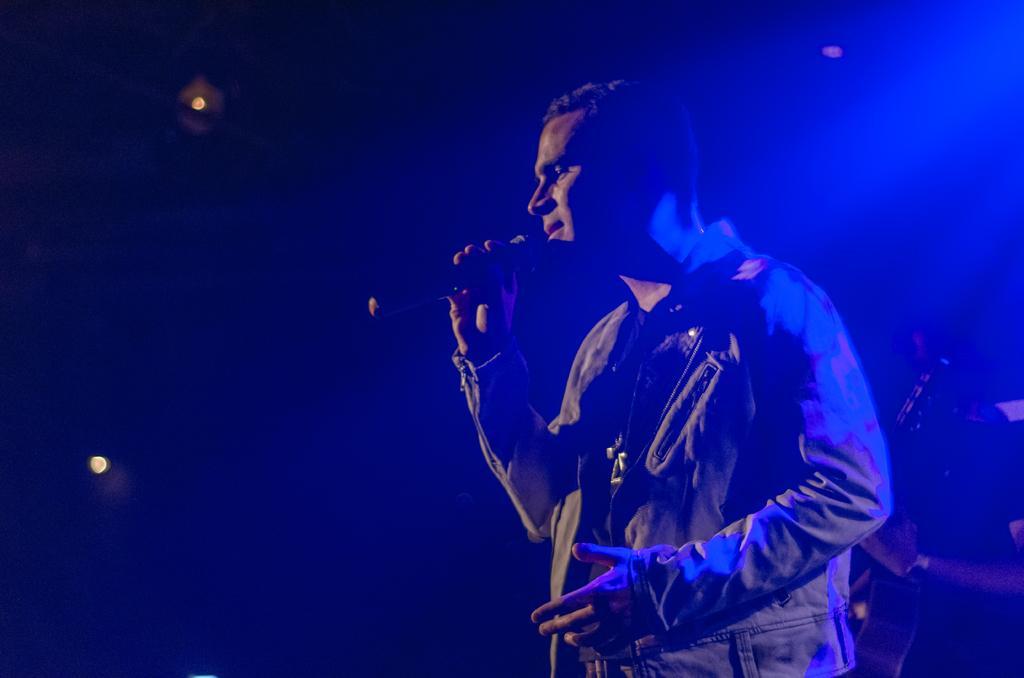How would you summarize this image in a sentence or two? In this picture I can see two persons standing. There is a person holding a mike and another person holding a guitar. I can see lights, and there is dark background. 